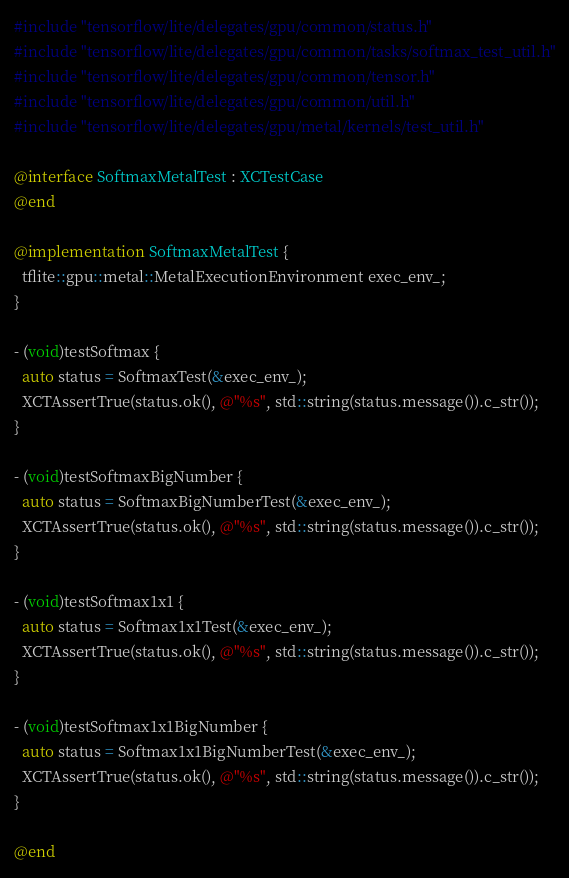<code> <loc_0><loc_0><loc_500><loc_500><_ObjectiveC_>#include "tensorflow/lite/delegates/gpu/common/status.h"
#include "tensorflow/lite/delegates/gpu/common/tasks/softmax_test_util.h"
#include "tensorflow/lite/delegates/gpu/common/tensor.h"
#include "tensorflow/lite/delegates/gpu/common/util.h"
#include "tensorflow/lite/delegates/gpu/metal/kernels/test_util.h"

@interface SoftmaxMetalTest : XCTestCase
@end

@implementation SoftmaxMetalTest {
  tflite::gpu::metal::MetalExecutionEnvironment exec_env_;
}

- (void)testSoftmax {
  auto status = SoftmaxTest(&exec_env_);
  XCTAssertTrue(status.ok(), @"%s", std::string(status.message()).c_str());
}

- (void)testSoftmaxBigNumber {
  auto status = SoftmaxBigNumberTest(&exec_env_);
  XCTAssertTrue(status.ok(), @"%s", std::string(status.message()).c_str());
}

- (void)testSoftmax1x1 {
  auto status = Softmax1x1Test(&exec_env_);
  XCTAssertTrue(status.ok(), @"%s", std::string(status.message()).c_str());
}

- (void)testSoftmax1x1BigNumber {
  auto status = Softmax1x1BigNumberTest(&exec_env_);
  XCTAssertTrue(status.ok(), @"%s", std::string(status.message()).c_str());
}

@end
</code> 